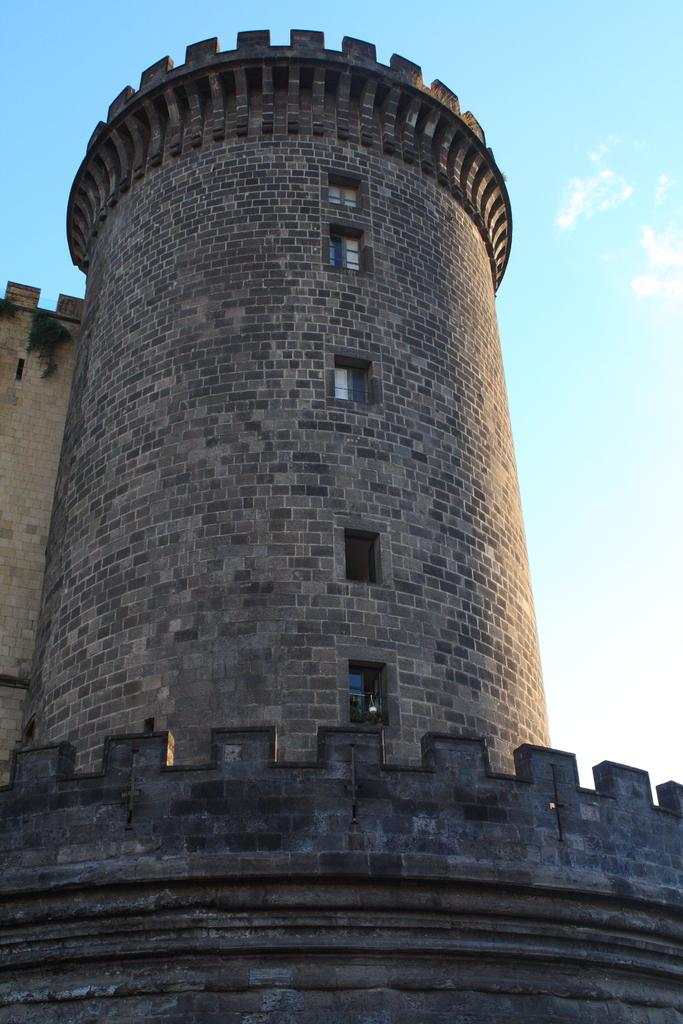What material is the building in the image made of? The building in the image is made of stone. What architectural feature can be seen on the building? The building has windows. What type of growth can be observed on the building in the image? There is no growth visible on the building in the image. Is there a guide present in the image to provide information about the building? There is no guide present in the image. Can you see any goats near or on the building in the image? There are no goats visible in the image. 